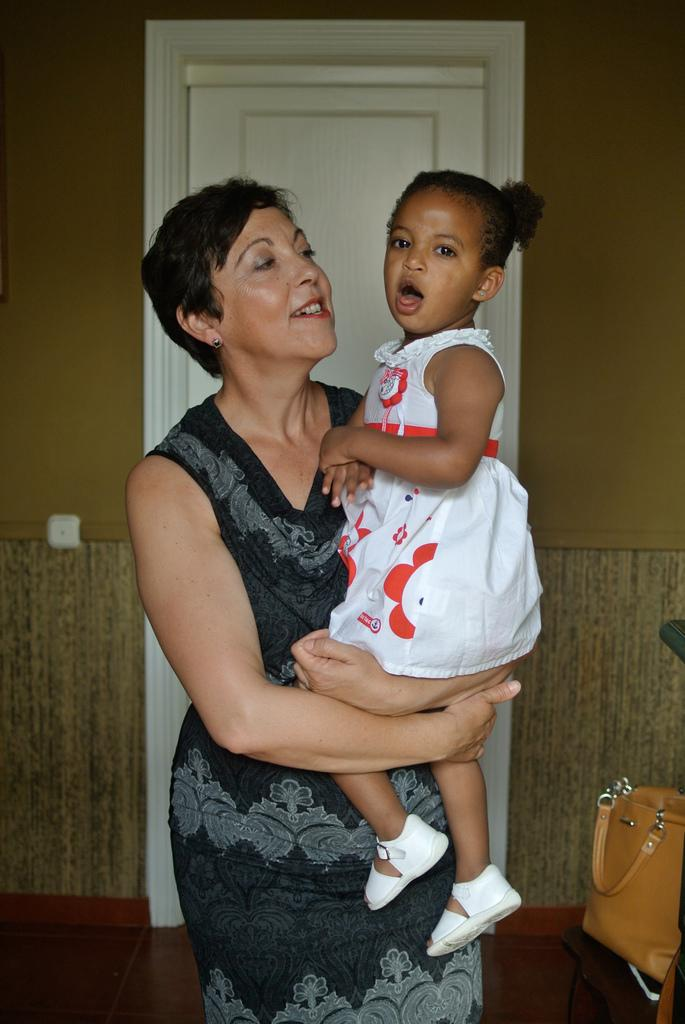Who is the main subject in the image? There is a woman in the image. What is the woman doing in the image? The woman is holding a girl. What is located behind the woman? There is a door behind the woman. What object is beside the woman? There is a bag beside the woman. What type of cattle can be seen grazing in the field behind the woman? There is no field or cattle present in the image. 